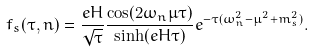Convert formula to latex. <formula><loc_0><loc_0><loc_500><loc_500>f _ { s } ( \tau , n ) = \frac { e H } { \sqrt { \tau } } \frac { \cos ( 2 \omega _ { n } \mu \tau ) } { \sinh ( e H \tau ) } e ^ { - \tau ( \omega _ { n } ^ { 2 } - \mu ^ { 2 } + m _ { s } ^ { 2 } ) } .</formula> 